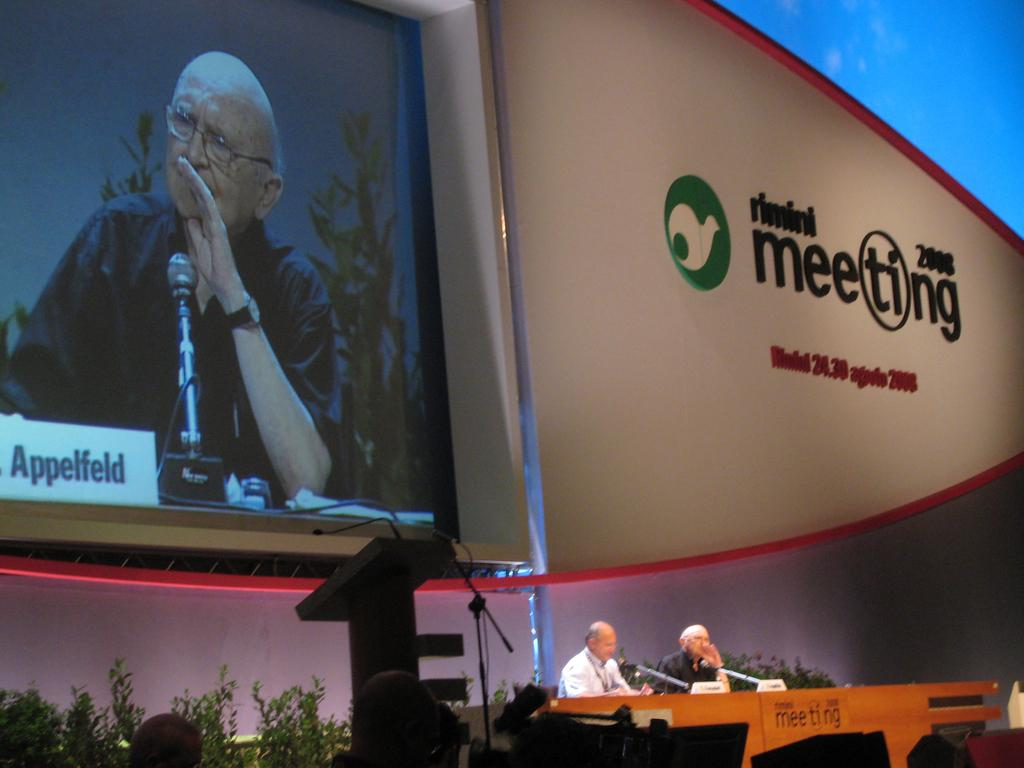Provide a one-sentence caption for the provided image. Two men giving a presentation at Rimini Meeeting 2008. 